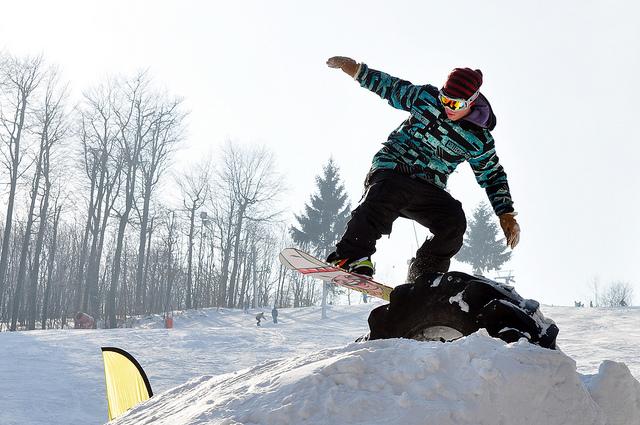Is the man on a ski slope?
Write a very short answer. Yes. What sport is the man doing?
Be succinct. Snowboarding. Do the trees look extra tall?
Quick response, please. Yes. 